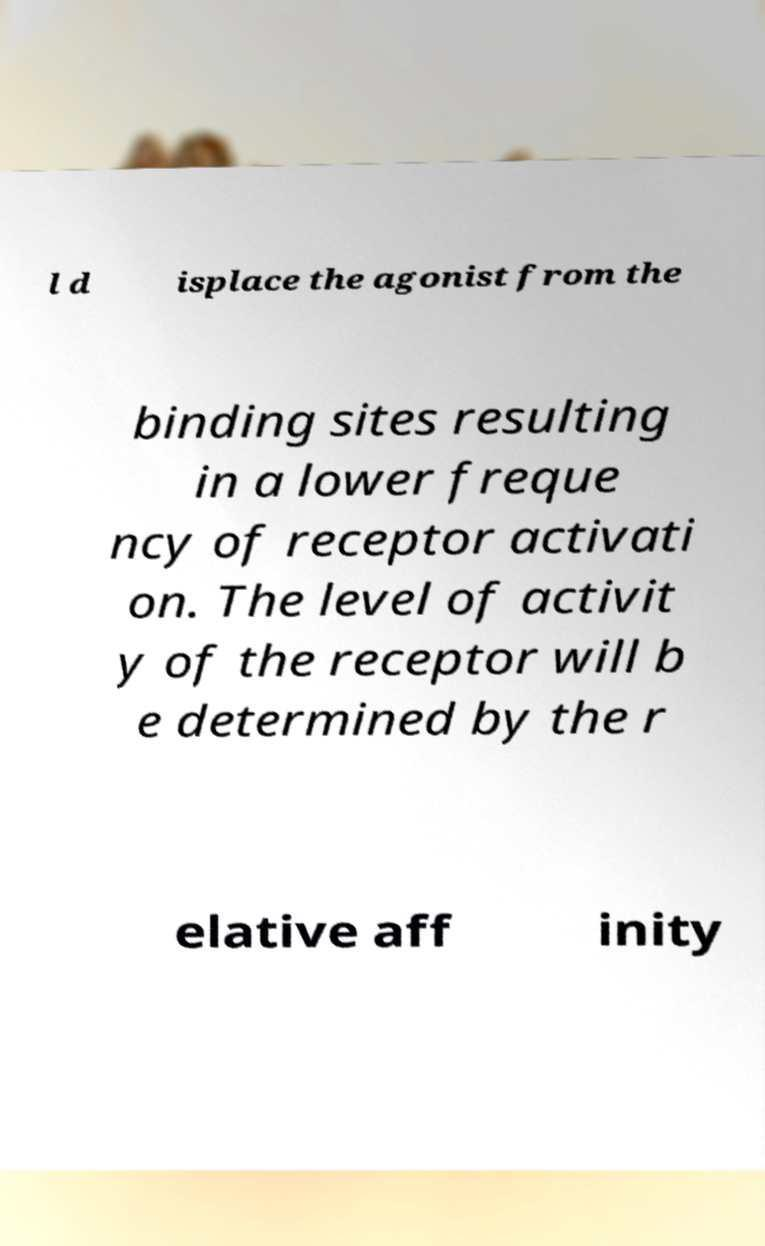There's text embedded in this image that I need extracted. Can you transcribe it verbatim? l d isplace the agonist from the binding sites resulting in a lower freque ncy of receptor activati on. The level of activit y of the receptor will b e determined by the r elative aff inity 